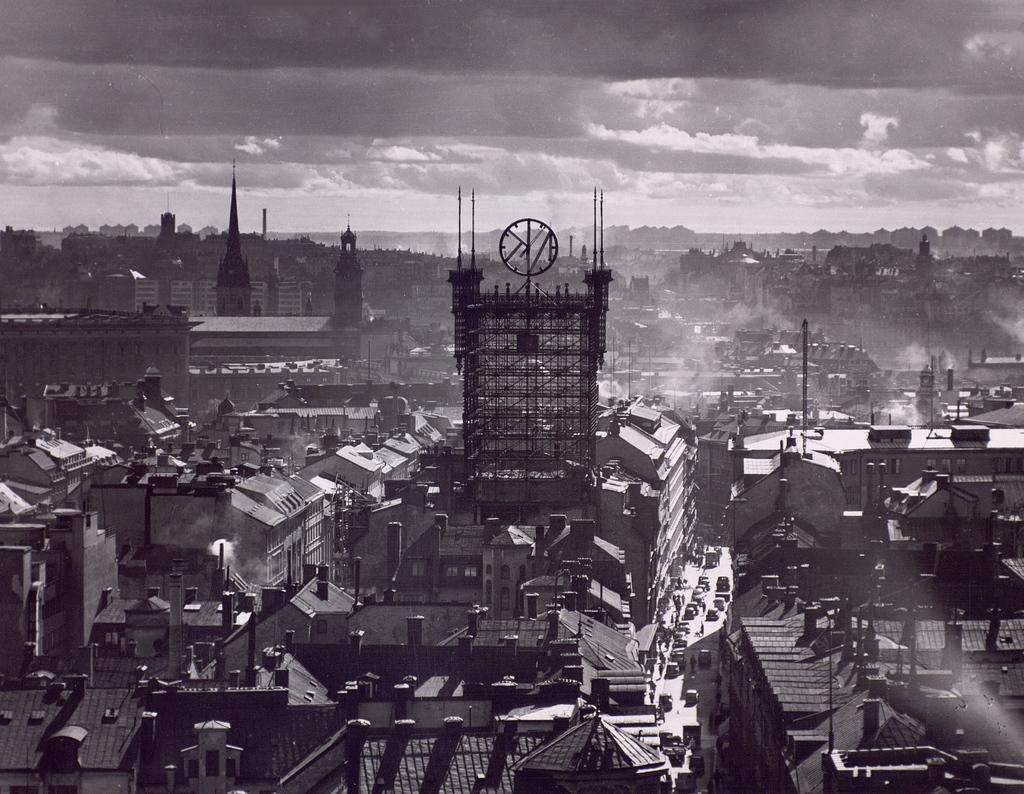How would you summarize this image in a sentence or two? In this image we can see buildings. At the top of the image there is sky and clouds. 